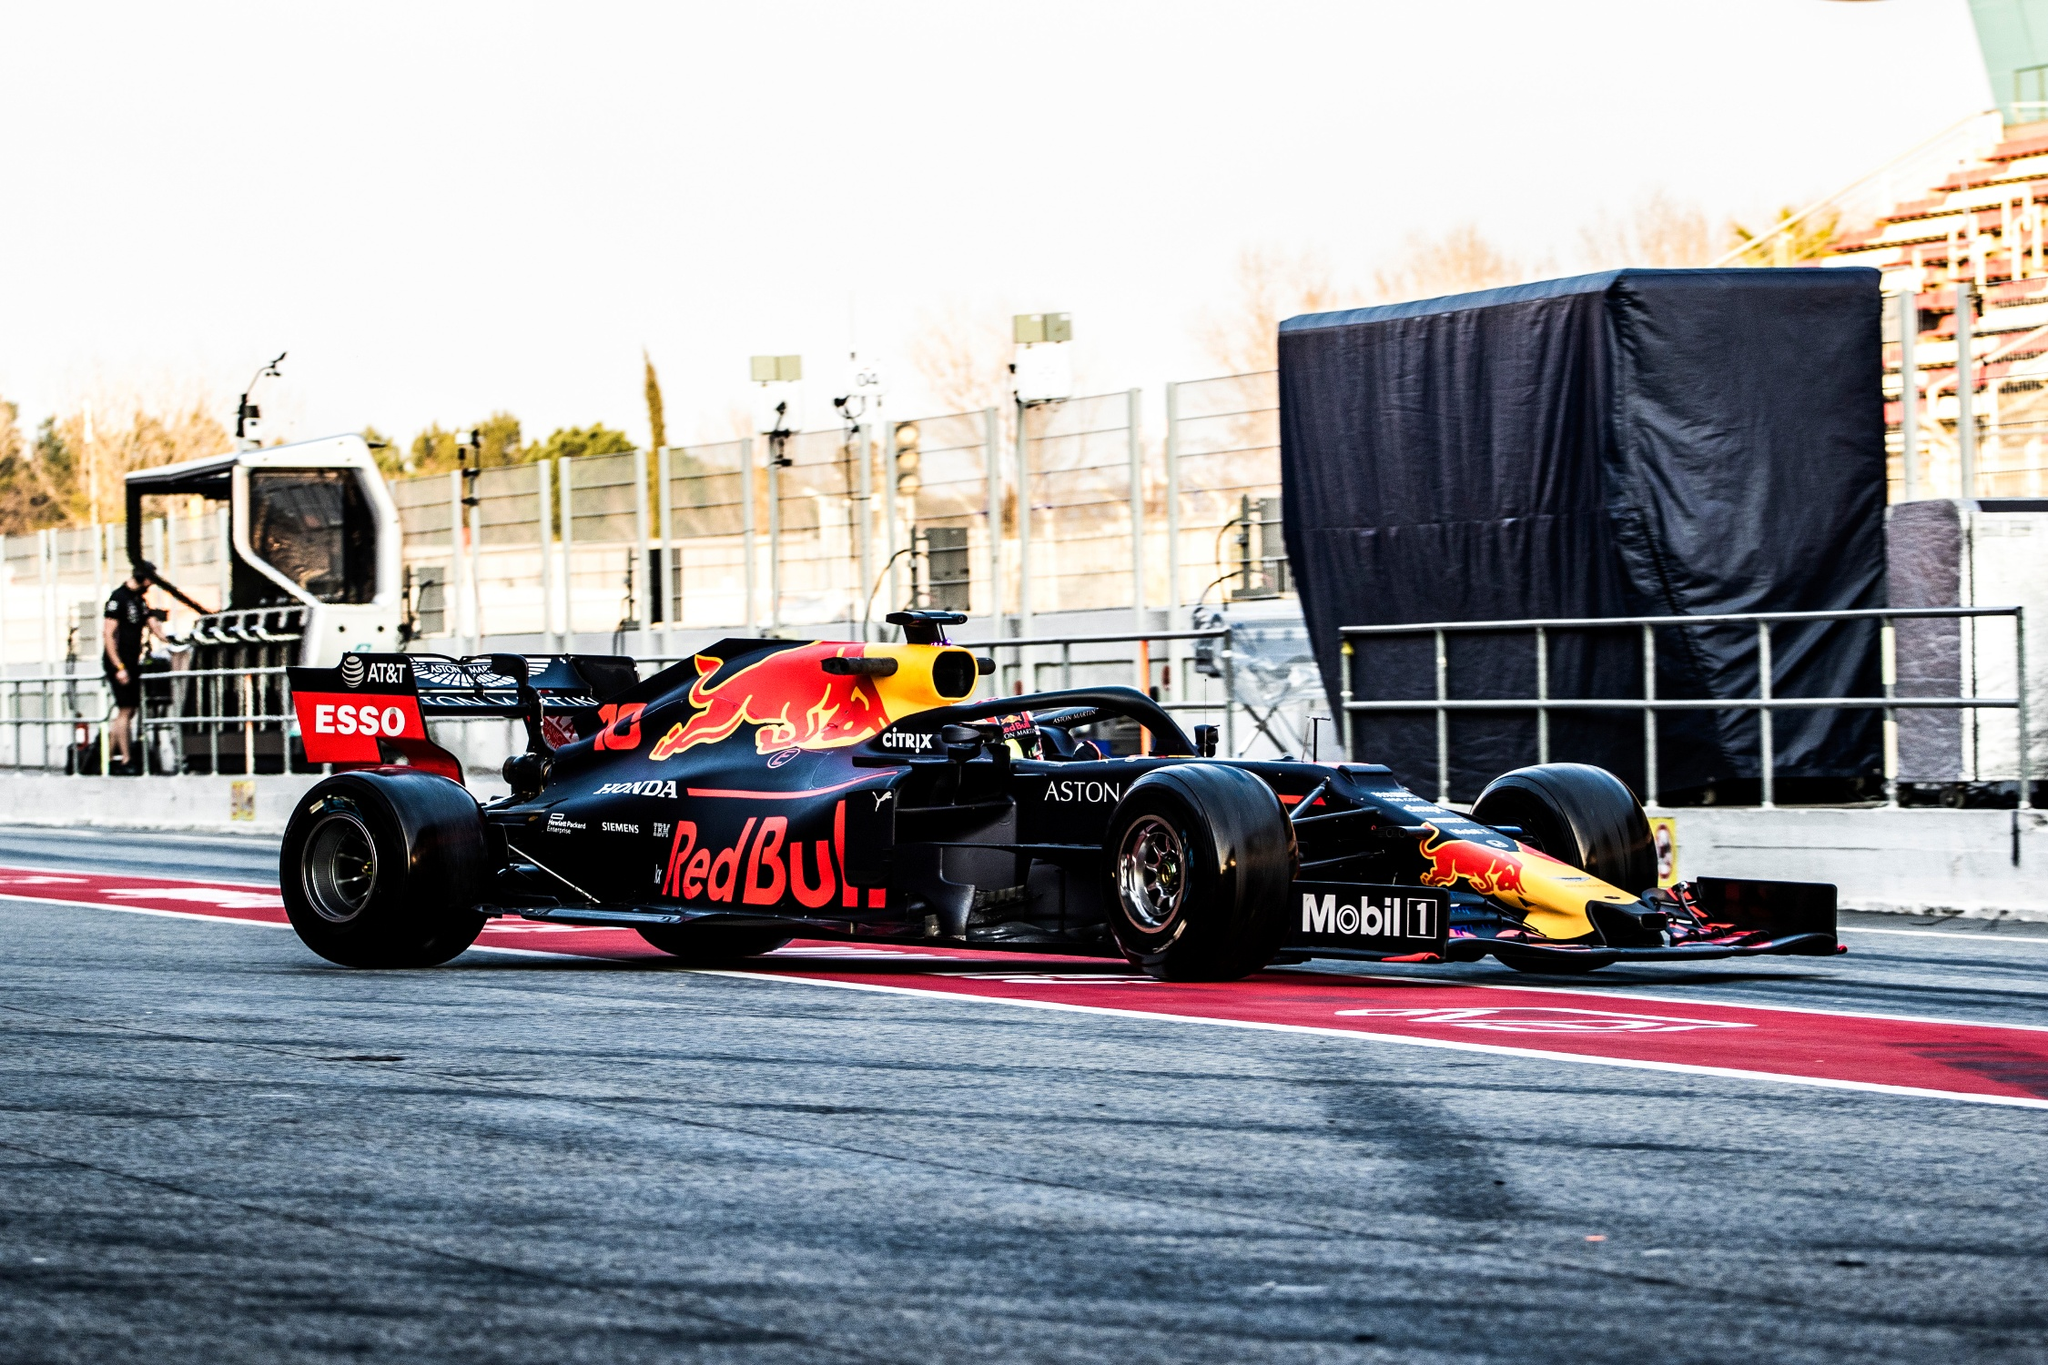Describe the atmosphere and energy in the scene depicted. The atmosphere in the image is electric and charged with intensity, typical of a Formula One race. The Red Bull car, painted in its signature red, blue, and yellow colors, hints at the high performance and competitive spirit of the sport. The vibe is one of urgency and precision, with the car moving swiftly on the track. The presence of crew members and heavy equipment in the background adds to the sense of a bustling, coordinated effort essential to the success of a race team. The overall scene captures both the glamour and the grit of Formula One racing. How important is teamwork in such a high-energy environment? Teamwork is absolutely crucial in the high-energy environment of Formula One racing. Every member of the team, from the driver to the engineers and pit crew, plays a pivotal role in the success of their car during the race. The teamwork manifests in various ways—strategizing the race plan, executing lightning-fast pit stops, maintaining the car's performance, and gathering real-time data for tactical decisions. Each split-second decision can make the difference between winning and losing, and this cohesion and skillful collaboration epitomize the essence of Formula One. 